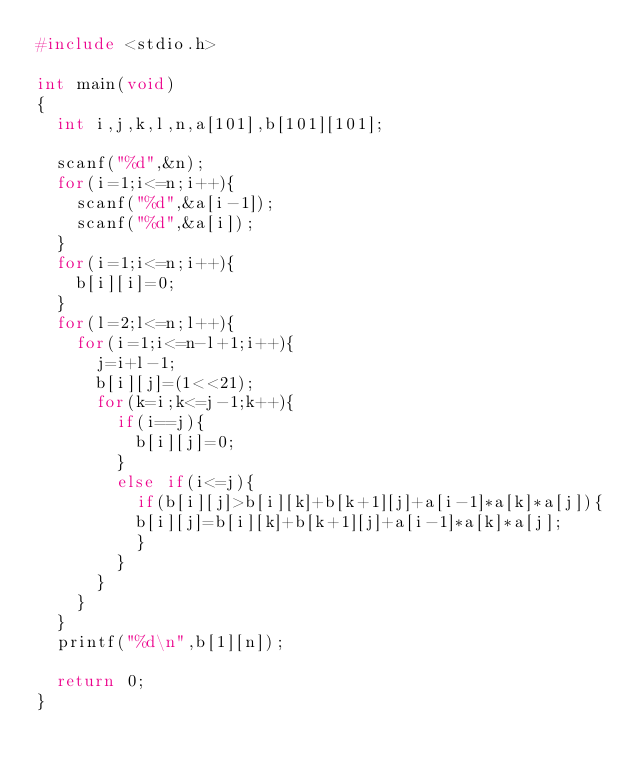Convert code to text. <code><loc_0><loc_0><loc_500><loc_500><_C_>#include <stdio.h>

int main(void)
{
  int i,j,k,l,n,a[101],b[101][101];

  scanf("%d",&n);
  for(i=1;i<=n;i++){
    scanf("%d",&a[i-1]);
    scanf("%d",&a[i]);
  }
  for(i=1;i<=n;i++){
    b[i][i]=0;
  }
  for(l=2;l<=n;l++){
    for(i=1;i<=n-l+1;i++){
      j=i+l-1;
      b[i][j]=(1<<21);
      for(k=i;k<=j-1;k++){
        if(i==j){
          b[i][j]=0;
        }
        else if(i<=j){
          if(b[i][j]>b[i][k]+b[k+1][j]+a[i-1]*a[k]*a[j]){
          b[i][j]=b[i][k]+b[k+1][j]+a[i-1]*a[k]*a[j];
          }
        }
      }
    }
  }
  printf("%d\n",b[1][n]);
  
  return 0;
}</code> 